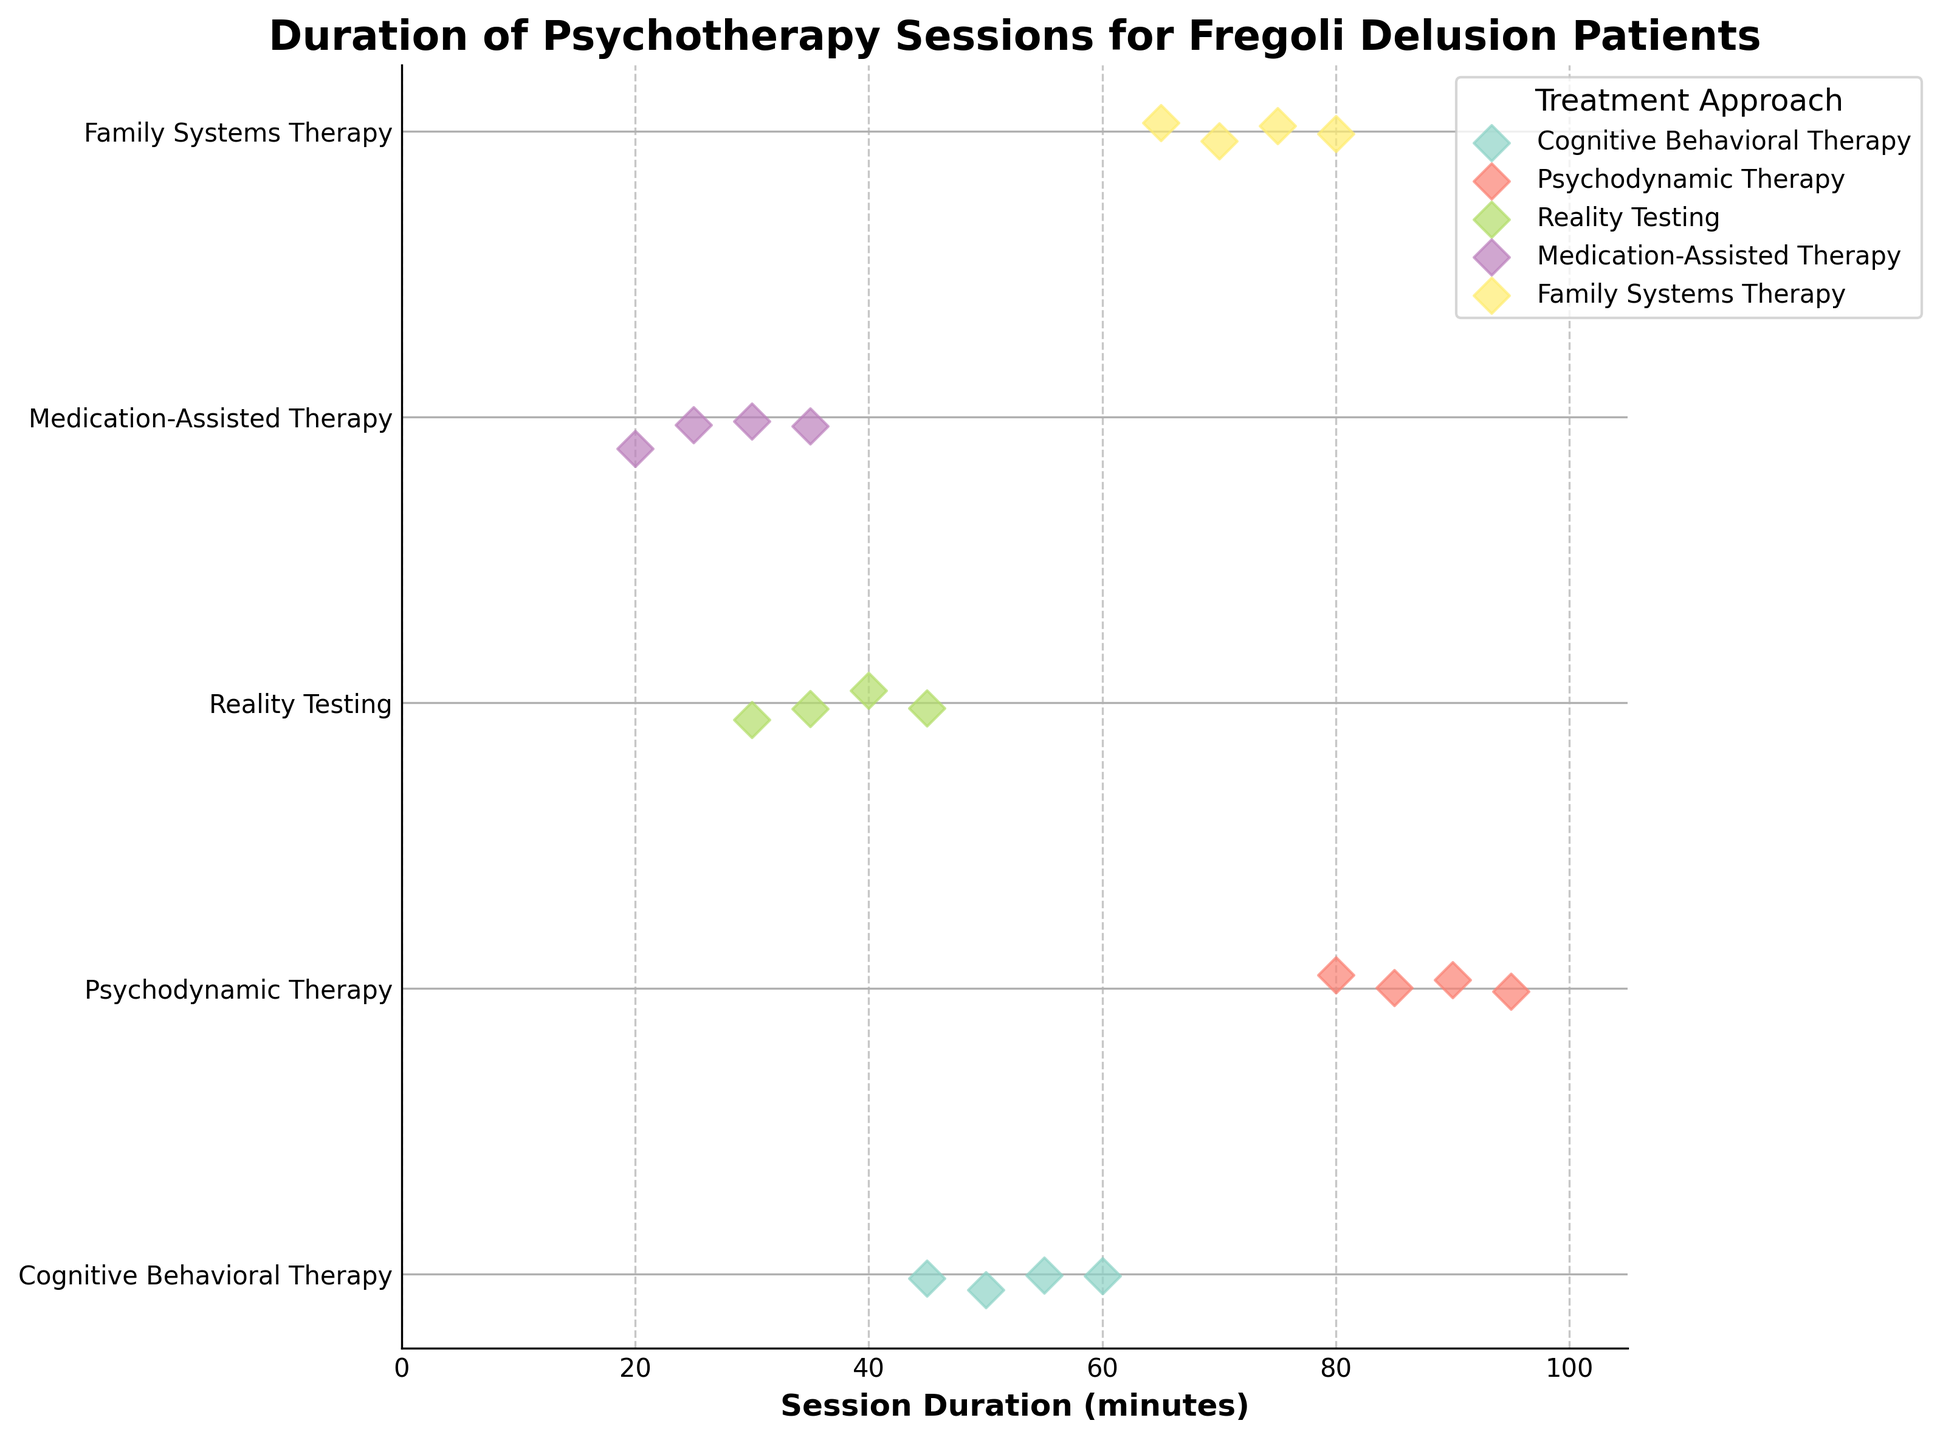What is the title of the plot? The title of the plot is usually found at the top of the figure. In this case, the title explicitly states that the plot shows the duration of psychotherapy sessions for patients with Fregoli Delusion.
Answer: Duration of Psychotherapy Sessions for Fregoli Delusion Patients How many treatment approaches are compared in the plot? By looking at the y-axis labels and the legend, we can count the different treatment approaches displayed in the figure.
Answer: 5 What is the range of treatment durations for Cognitive Behavioral Therapy? By observing the scatter points representing Cognitive Behavioral Therapy on the x-axis, we can see the minimum and maximum session durations.
Answer: 45 to 60 minutes Which treatment approach has the shortest average session duration? To determine this, calculate the average session duration for each treatment by averaging the corresponding points on the x-axis. Medication-Assisted Therapy has durations of 30, 25, 35, and 20 minutes, averaging 27.5 minutes, which is the shortest among the shown groups.
Answer: Medication-Assisted Therapy Which treatment approach shows the most variation in session duration? To find the most varied approach, compare the spread of the scatter points for each treatment on the x-axis. The more spread out the points, the higher the variation. Psychodynamic Therapy shows durations ranging from 80 to 95 minutes, hence showing the most variation.
Answer: Psychodynamic Therapy How does the duration of sessions for Family Systems Therapy compare to Reality Testing? By comparing the scatter points on the x-axis for both Family Systems Therapy and Reality Testing, we can see which has generally longer or shorter session durations. Family Systems Therapy durations (65, 70, 75, 80) are higher than Reality Testing durations (30, 35, 40, 45).
Answer: Family Systems Therapy sessions are generally longer than Reality Testing sessions What is the median session duration for Family Systems Therapy? The median is the middle value when data points are ordered. For Family Systems Therapy, the durations are 65, 70, 75, and 80 minutes. The median is the average of the middle two values (70 and 75): (70+75)/2.
Answer: 72.5 minutes What is the maximal session duration observed in the plot? By examining the scatter points across all approaches, the highest value on the x-axis represents the maximum session duration.
Answer: 95 minutes For which treatment approach is there a session that lasts exactly 60 minutes? Examining the scatter points, we look for the one located at the 60-minute mark on the x-axis and identify the corresponding approach.
Answer: Cognitive Behavioral Therapy How are the session durations for Reality Testing distributed compared to Medication-Assisted Therapy? Compare the scatter points along the x-axis for Reality Testing and Medication-Assisted Therapy. Reality Testing durations (30, 35, 40, 45) have higher and more varied session lengths than Medication-Assisted Therapy durations (20, 25, 30, 35).
Answer: Reality Testing sessions are generally longer and more varied compared to Medication-Assisted Therapy 